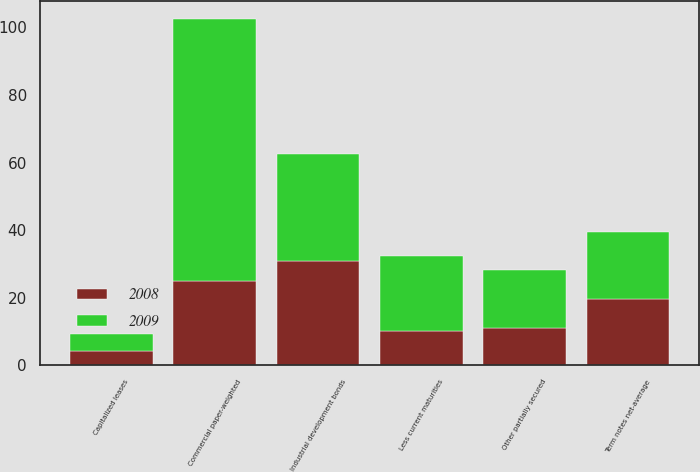Convert chart to OTSL. <chart><loc_0><loc_0><loc_500><loc_500><stacked_bar_chart><ecel><fcel>Term notes net-average<fcel>Industrial development bonds<fcel>Capitalized leases<fcel>Commercial paper-weighted<fcel>Other partially secured<fcel>Less current maturities<nl><fcel>2008<fcel>19.7<fcel>31<fcel>4.4<fcel>25<fcel>11.2<fcel>10.1<nl><fcel>2009<fcel>19.7<fcel>31.5<fcel>5<fcel>77.6<fcel>17<fcel>22.4<nl></chart> 